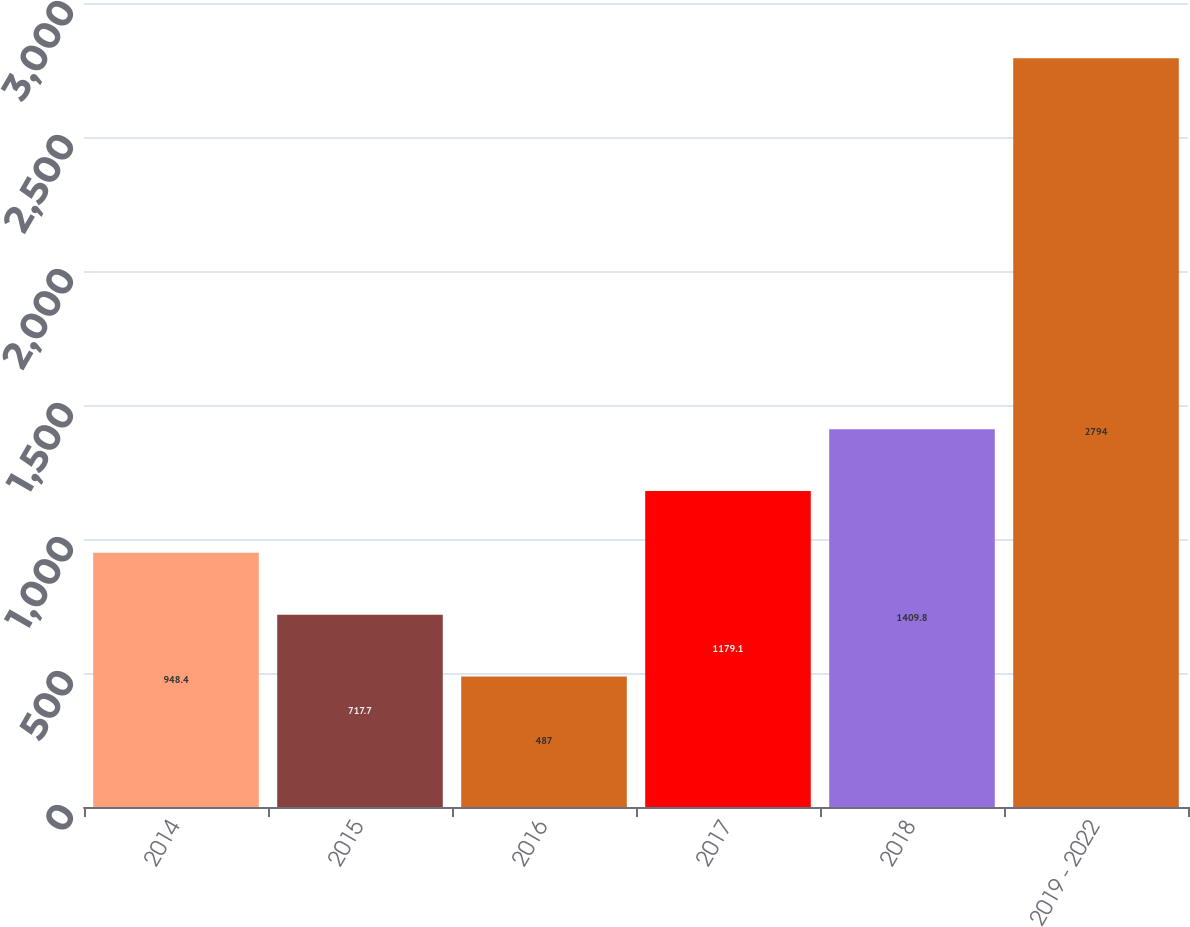Convert chart. <chart><loc_0><loc_0><loc_500><loc_500><bar_chart><fcel>2014<fcel>2015<fcel>2016<fcel>2017<fcel>2018<fcel>2019 - 2022<nl><fcel>948.4<fcel>717.7<fcel>487<fcel>1179.1<fcel>1409.8<fcel>2794<nl></chart> 